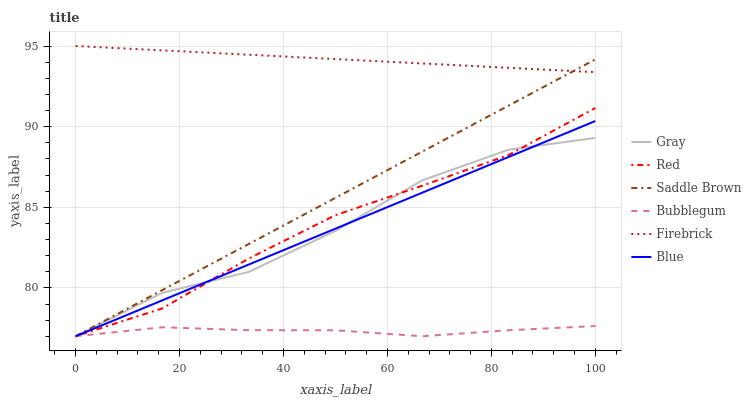Does Bubblegum have the minimum area under the curve?
Answer yes or no. Yes. Does Firebrick have the maximum area under the curve?
Answer yes or no. Yes. Does Gray have the minimum area under the curve?
Answer yes or no. No. Does Gray have the maximum area under the curve?
Answer yes or no. No. Is Firebrick the smoothest?
Answer yes or no. Yes. Is Gray the roughest?
Answer yes or no. Yes. Is Gray the smoothest?
Answer yes or no. No. Is Firebrick the roughest?
Answer yes or no. No. Does Firebrick have the lowest value?
Answer yes or no. No. Does Gray have the highest value?
Answer yes or no. No. Is Red less than Firebrick?
Answer yes or no. Yes. Is Firebrick greater than Red?
Answer yes or no. Yes. Does Red intersect Firebrick?
Answer yes or no. No. 